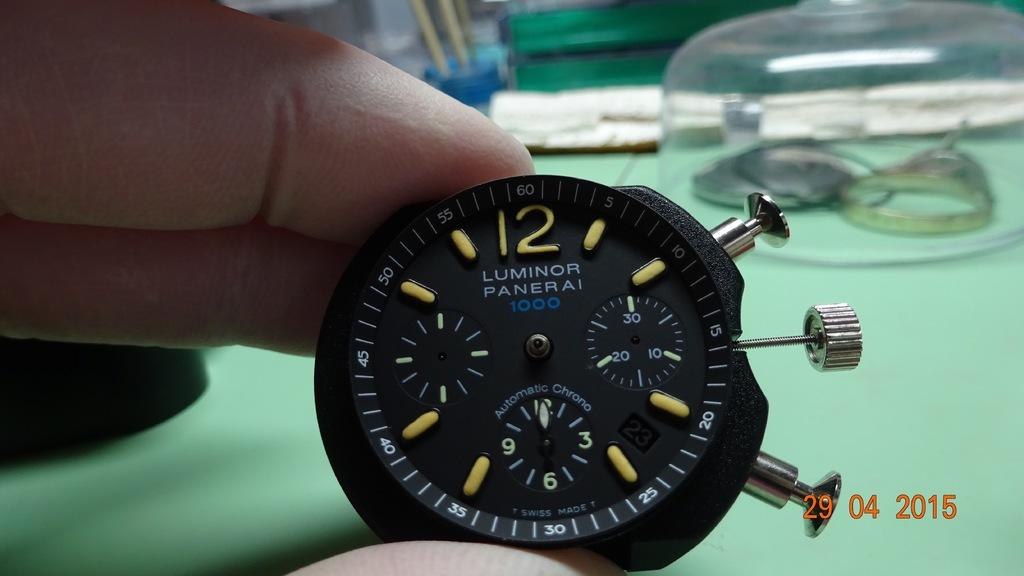<image>
Summarize the visual content of the image. A photo of an elegant black and gold stopwatch bears a 2015 time stamp. 